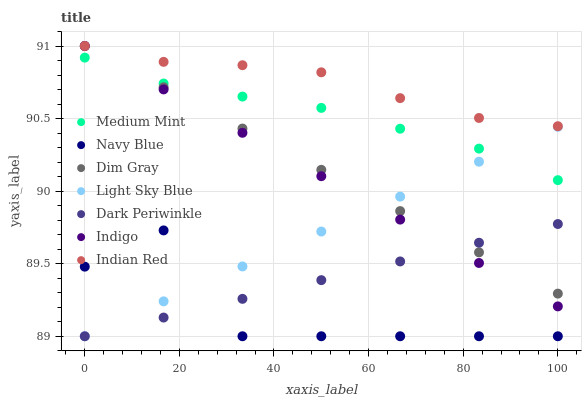Does Navy Blue have the minimum area under the curve?
Answer yes or no. Yes. Does Indian Red have the maximum area under the curve?
Answer yes or no. Yes. Does Dim Gray have the minimum area under the curve?
Answer yes or no. No. Does Dim Gray have the maximum area under the curve?
Answer yes or no. No. Is Indigo the smoothest?
Answer yes or no. Yes. Is Navy Blue the roughest?
Answer yes or no. Yes. Is Dim Gray the smoothest?
Answer yes or no. No. Is Dim Gray the roughest?
Answer yes or no. No. Does Navy Blue have the lowest value?
Answer yes or no. Yes. Does Dim Gray have the lowest value?
Answer yes or no. No. Does Indian Red have the highest value?
Answer yes or no. Yes. Does Navy Blue have the highest value?
Answer yes or no. No. Is Navy Blue less than Indigo?
Answer yes or no. Yes. Is Indian Red greater than Dark Periwinkle?
Answer yes or no. Yes. Does Indian Red intersect Indigo?
Answer yes or no. Yes. Is Indian Red less than Indigo?
Answer yes or no. No. Is Indian Red greater than Indigo?
Answer yes or no. No. Does Navy Blue intersect Indigo?
Answer yes or no. No. 